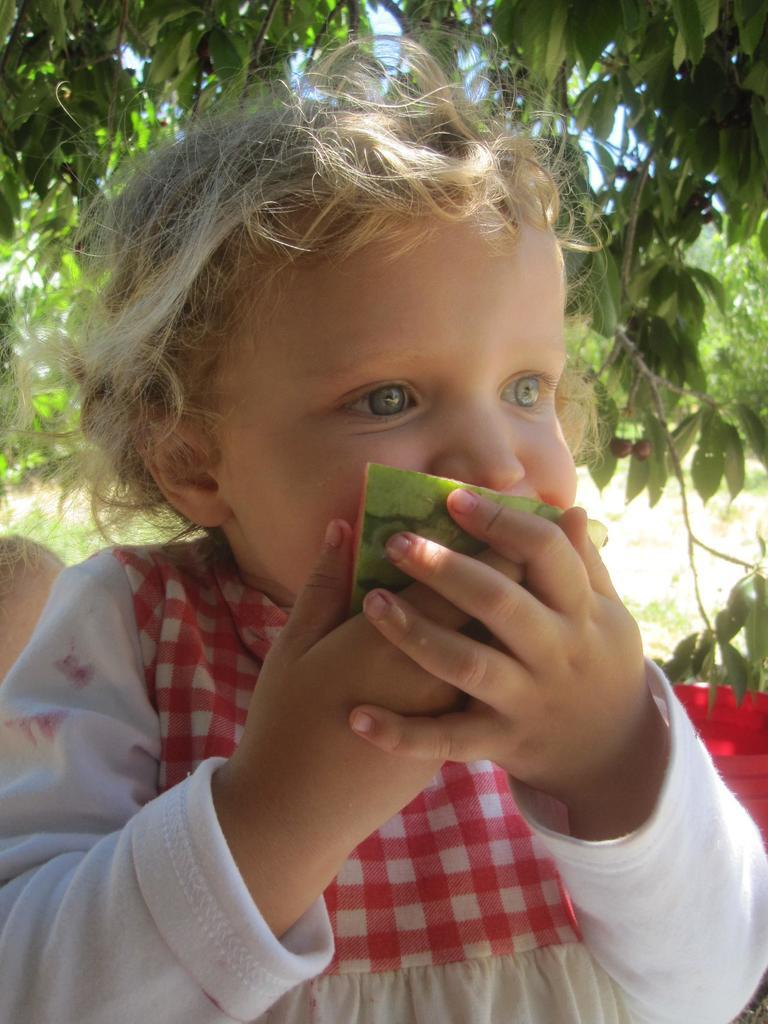What is the main subject of the image? The main subject of the image is a child. What is the child doing in the image? The child is eating a fruit in the image. What can be seen in the background of the image? There are trees and the sky visible in the background of the image. What type of apparel is the child wearing in the image? The provided facts do not mention the child's apparel, so we cannot determine what type of clothing the child is wearing. Are there any pets visible in the image? There is no mention of pets in the provided facts, so we cannot determine if any pets are present in the image. 